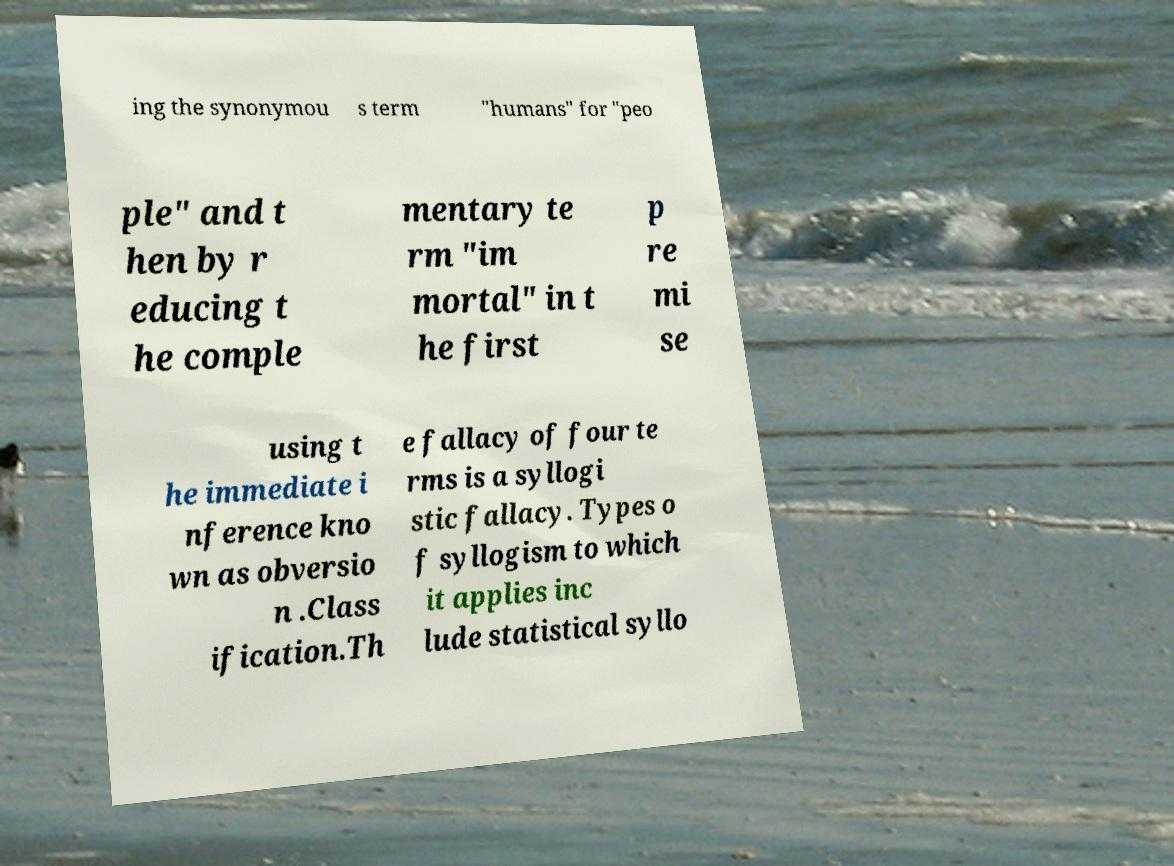I need the written content from this picture converted into text. Can you do that? ing the synonymou s term "humans" for "peo ple" and t hen by r educing t he comple mentary te rm "im mortal" in t he first p re mi se using t he immediate i nference kno wn as obversio n .Class ification.Th e fallacy of four te rms is a syllogi stic fallacy. Types o f syllogism to which it applies inc lude statistical syllo 